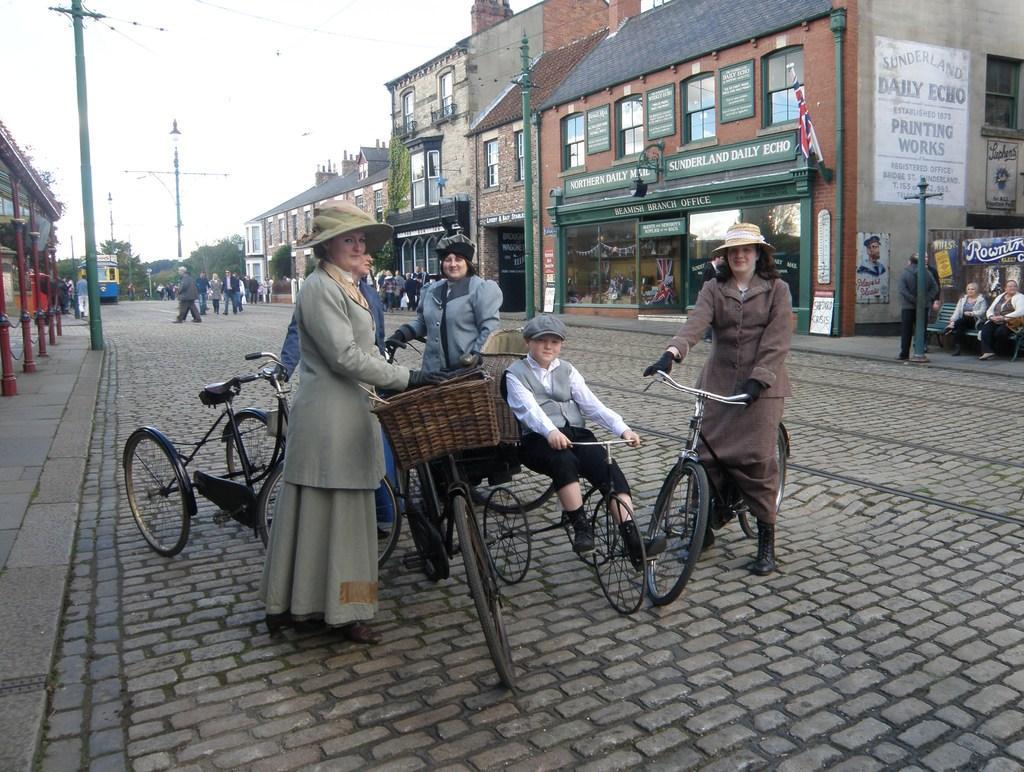How would you summarize this image in a sentence or two? An outdoor picture. Group of people are holding bicycle and sitting on bicycle. This 2 women wore jackets and hats. This boy wore cap and jacket. Far there are number of buildings with windows and doors. On this wall there is a posters. Poles are far away from each other. Sky is in white color. People are sitting on a bench. This man is walking on a road. Far there are number of trees. Vehicles on road. In-front of this bicycle there is a basket. 